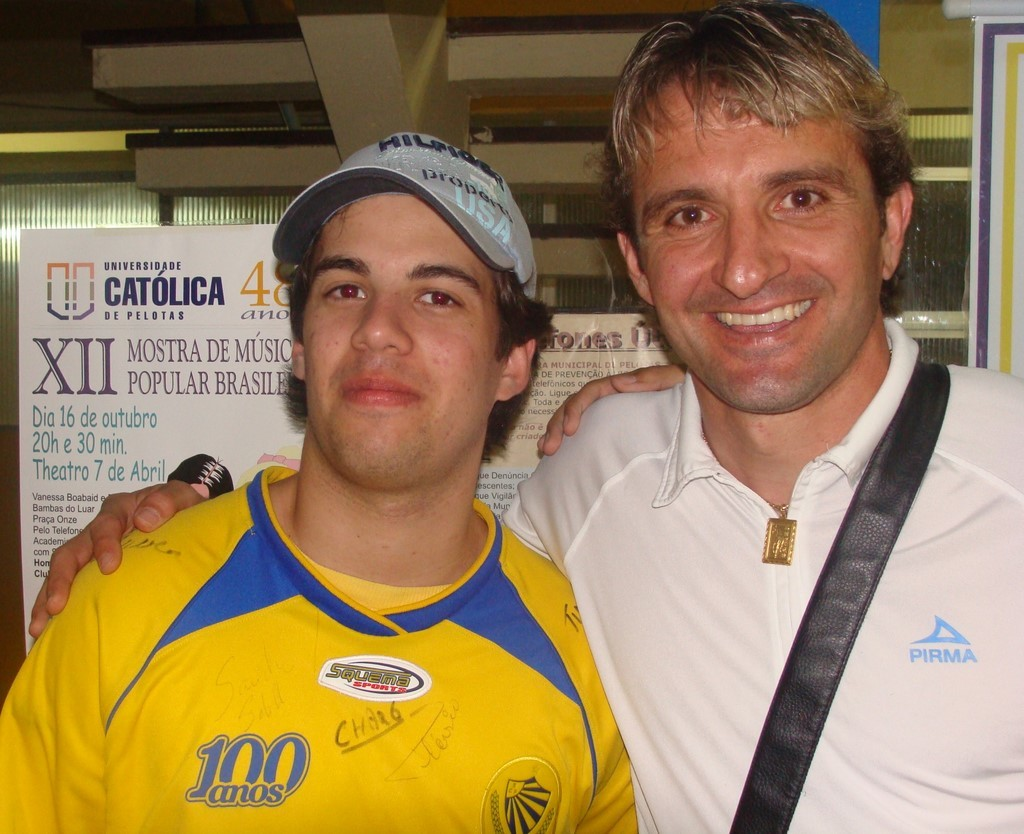What does the text on the backdrop and the shirt in the image signify? The text on the backdrop represents a university event, specifically the 'XII Mostra de Música Popular Brasileira' organized by Universidade Catolica de Pelotas, implying a music festival centered on Brazilian popular music. The text '100 anos' on the yellow shirt might signify a centennial celebration connected to the event or the university. 